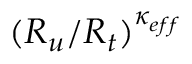<formula> <loc_0><loc_0><loc_500><loc_500>( R _ { u } / R _ { t } ) ^ { \kappa _ { e f f } }</formula> 